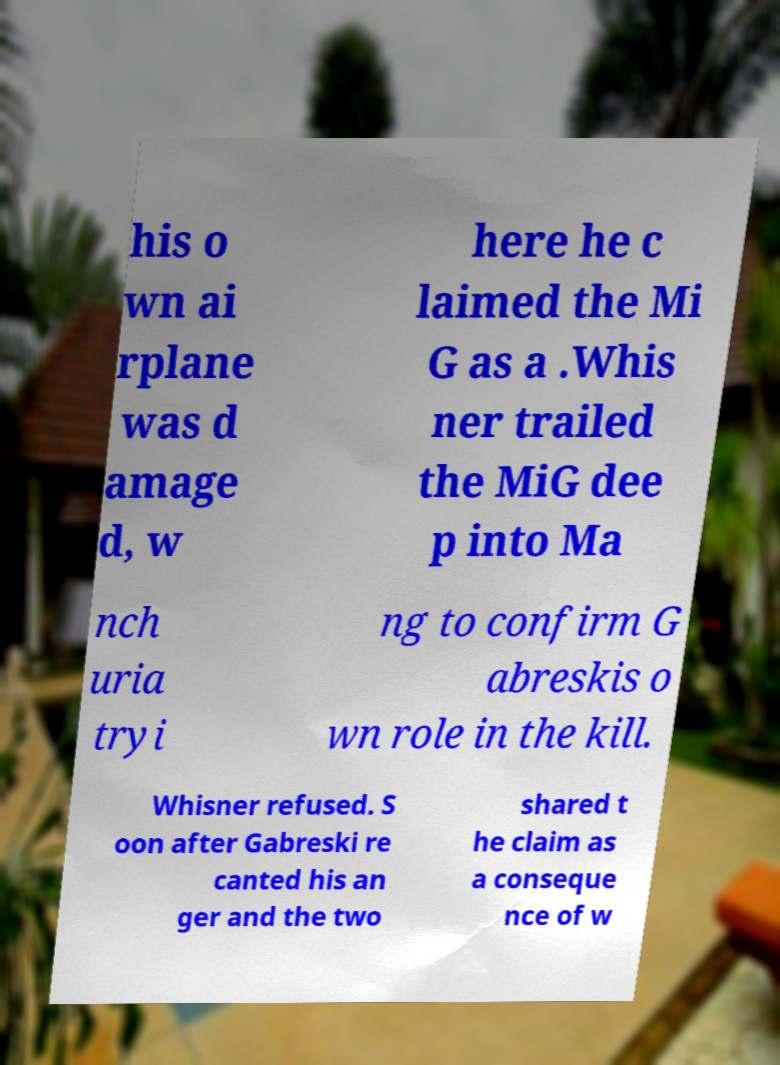Please identify and transcribe the text found in this image. his o wn ai rplane was d amage d, w here he c laimed the Mi G as a .Whis ner trailed the MiG dee p into Ma nch uria tryi ng to confirm G abreskis o wn role in the kill. Whisner refused. S oon after Gabreski re canted his an ger and the two shared t he claim as a conseque nce of w 